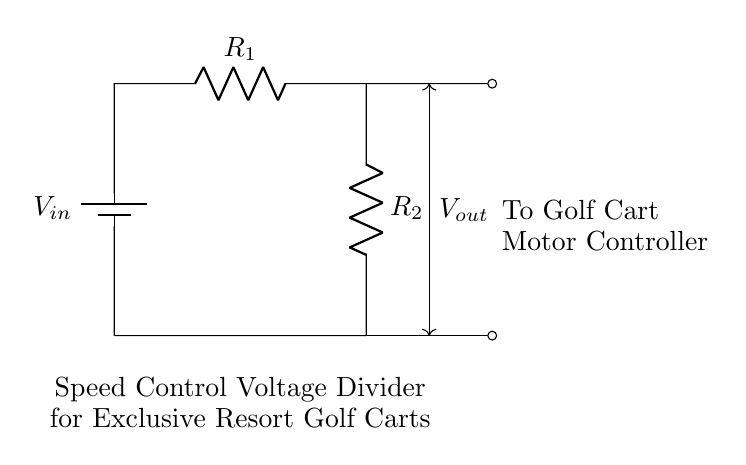What is the input voltage in this circuit? The input voltage, denoted as V-in, is the voltage provided by the battery connected at the top of the circuit diagram. It represents the total voltage supplied to the voltage divider circuit.
Answer: V-in What do the resistors in this circuit do? The resistors R1 and R2 form a voltage divider, where they adjust the output voltage (V-out) based on the resistance values. The interaction between these resistors allows for varying output voltage, which controls the speed of the golf cart.
Answer: Adjust output voltage How many resistors are used in this voltage divider? There are two resistors illustrated in the circuit: R1 and R2. Their arrangement is essential for the voltage division process that controls the speed of the golf cart.
Answer: Two What is the purpose of the output voltage V-out? The output voltage V-out is connected to the motor controller, providing the specific voltage required to adjust the speed of the electric golf cart effectively. This voltage output is lower than the input voltage based on the resistor values.
Answer: Speed control What happens if R1 has a very high resistance compared to R2? If R1's resistance is significantly higher than R2's, the output voltage V-out will be closer to V-in, resulting in a faster speed for the golf cart as more voltage is applied to the motor controller. The rule of voltage division indicates a higher proportion of the total voltage would drop across R1.
Answer: Higher output voltage What occurs if R2 is short-circuited? If R2 becomes short-circuited, the output voltage V-out would drop to zero since the current would bypass R2 entirely, leading to no control over the speed of the golf cart. This condition would effectively stop the voltage divider from functioning.
Answer: Zero voltage output 